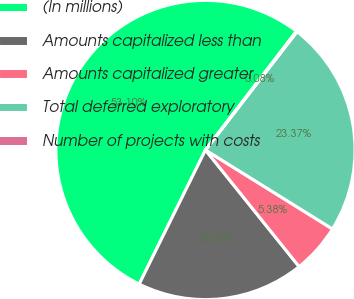Convert chart. <chart><loc_0><loc_0><loc_500><loc_500><pie_chart><fcel>(In millions)<fcel>Amounts capitalized less than<fcel>Amounts capitalized greater<fcel>Total deferred exploratory<fcel>Number of projects with costs<nl><fcel>53.1%<fcel>18.07%<fcel>5.38%<fcel>23.37%<fcel>0.08%<nl></chart> 